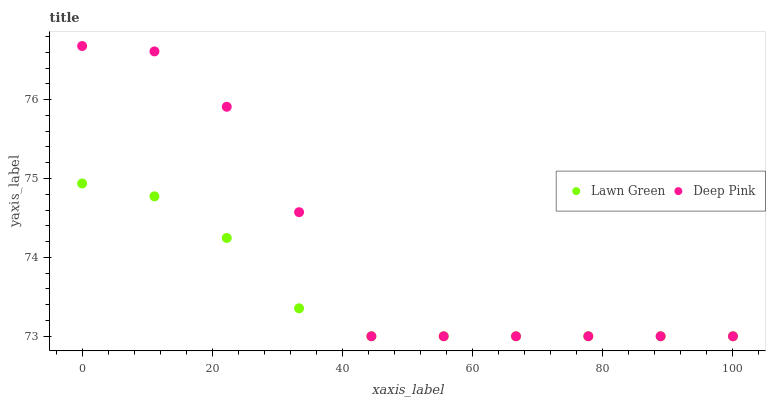Does Lawn Green have the minimum area under the curve?
Answer yes or no. Yes. Does Deep Pink have the maximum area under the curve?
Answer yes or no. Yes. Does Deep Pink have the minimum area under the curve?
Answer yes or no. No. Is Lawn Green the smoothest?
Answer yes or no. Yes. Is Deep Pink the roughest?
Answer yes or no. Yes. Is Deep Pink the smoothest?
Answer yes or no. No. Does Lawn Green have the lowest value?
Answer yes or no. Yes. Does Deep Pink have the highest value?
Answer yes or no. Yes. Does Deep Pink intersect Lawn Green?
Answer yes or no. Yes. Is Deep Pink less than Lawn Green?
Answer yes or no. No. Is Deep Pink greater than Lawn Green?
Answer yes or no. No. 